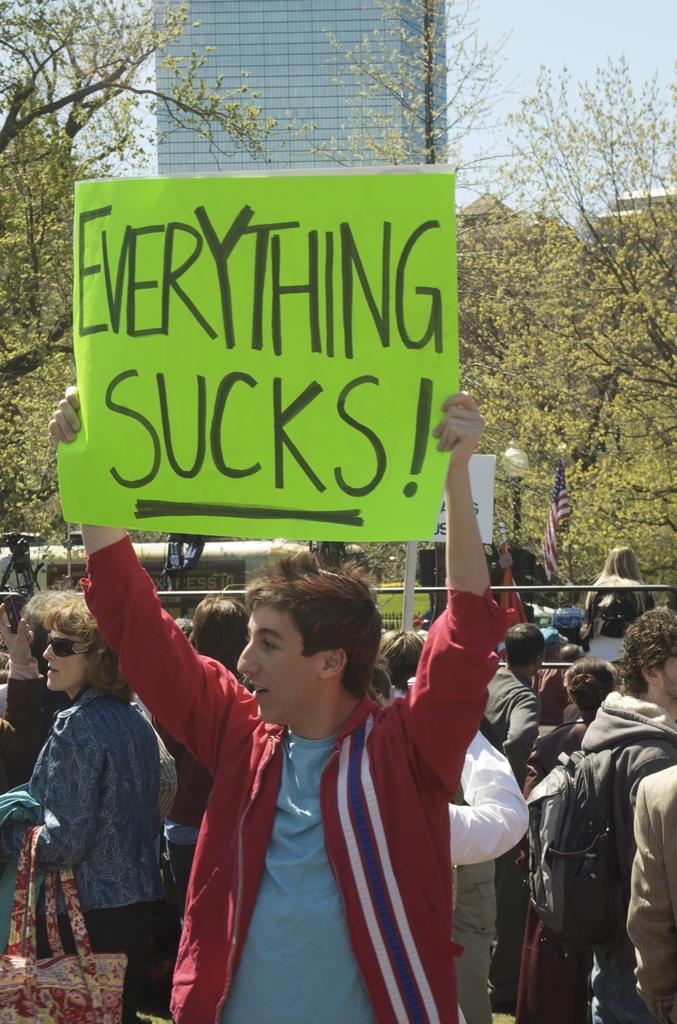In one or two sentences, can you explain what this image depicts? In this picture we can see a man standing and holding a poster with his hands and at the back of him we can see some people, bags, trees, buildings, flag and in the background we can see the sky. 